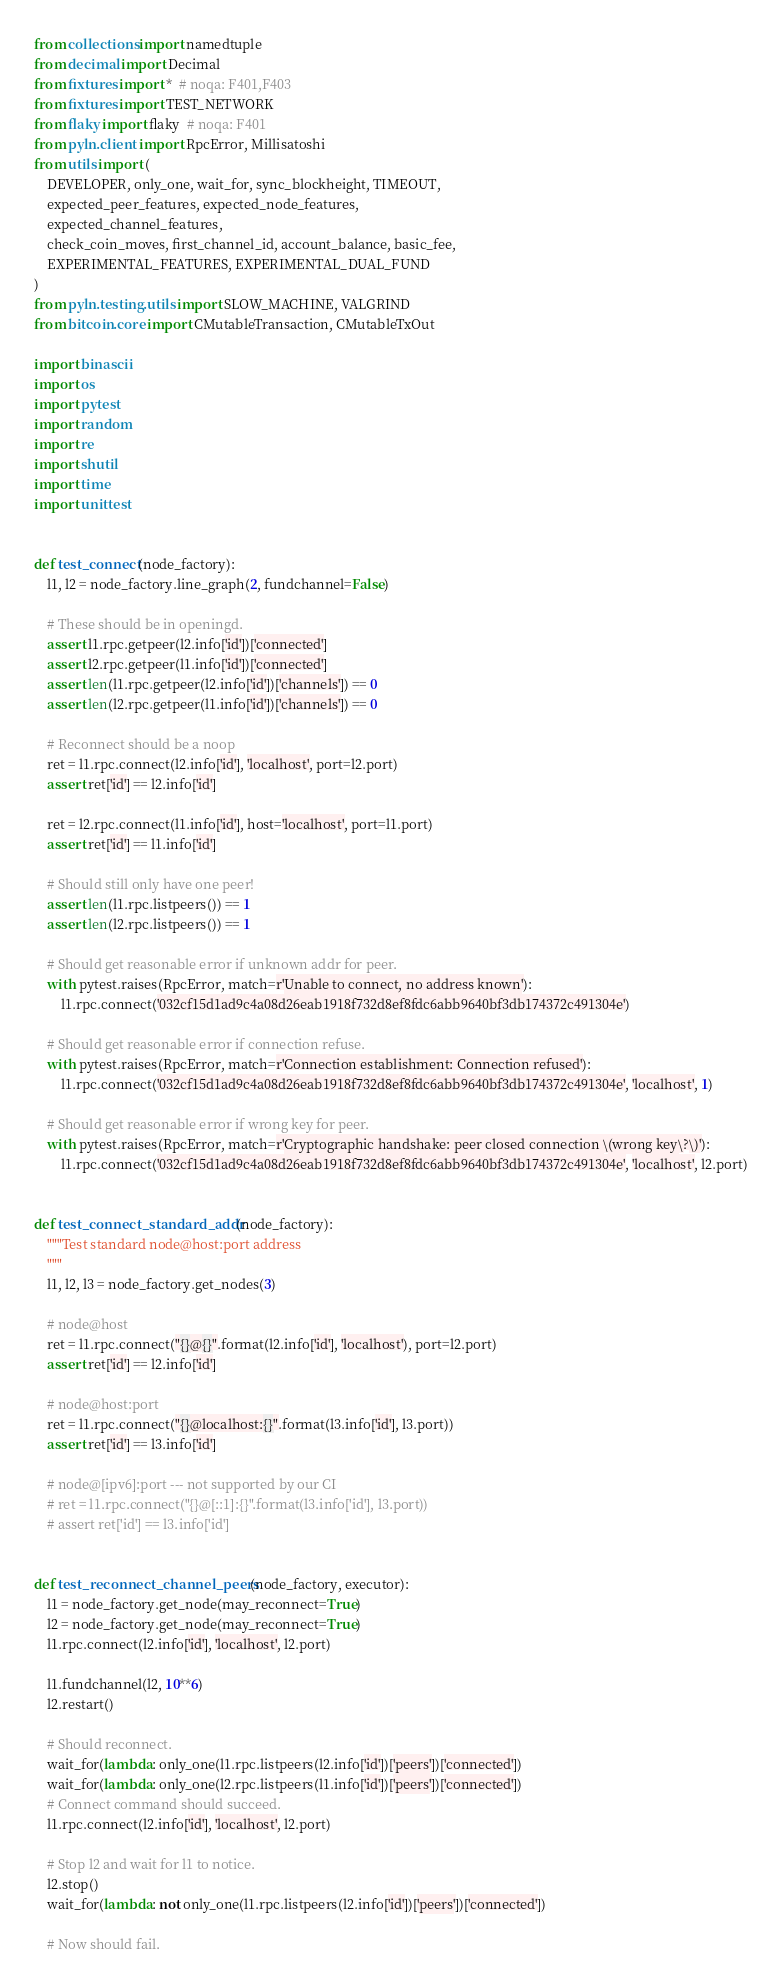Convert code to text. <code><loc_0><loc_0><loc_500><loc_500><_Python_>from collections import namedtuple
from decimal import Decimal
from fixtures import *  # noqa: F401,F403
from fixtures import TEST_NETWORK
from flaky import flaky  # noqa: F401
from pyln.client import RpcError, Millisatoshi
from utils import (
    DEVELOPER, only_one, wait_for, sync_blockheight, TIMEOUT,
    expected_peer_features, expected_node_features,
    expected_channel_features,
    check_coin_moves, first_channel_id, account_balance, basic_fee,
    EXPERIMENTAL_FEATURES, EXPERIMENTAL_DUAL_FUND
)
from pyln.testing.utils import SLOW_MACHINE, VALGRIND
from bitcoin.core import CMutableTransaction, CMutableTxOut

import binascii
import os
import pytest
import random
import re
import shutil
import time
import unittest


def test_connect(node_factory):
    l1, l2 = node_factory.line_graph(2, fundchannel=False)

    # These should be in openingd.
    assert l1.rpc.getpeer(l2.info['id'])['connected']
    assert l2.rpc.getpeer(l1.info['id'])['connected']
    assert len(l1.rpc.getpeer(l2.info['id'])['channels']) == 0
    assert len(l2.rpc.getpeer(l1.info['id'])['channels']) == 0

    # Reconnect should be a noop
    ret = l1.rpc.connect(l2.info['id'], 'localhost', port=l2.port)
    assert ret['id'] == l2.info['id']

    ret = l2.rpc.connect(l1.info['id'], host='localhost', port=l1.port)
    assert ret['id'] == l1.info['id']

    # Should still only have one peer!
    assert len(l1.rpc.listpeers()) == 1
    assert len(l2.rpc.listpeers()) == 1

    # Should get reasonable error if unknown addr for peer.
    with pytest.raises(RpcError, match=r'Unable to connect, no address known'):
        l1.rpc.connect('032cf15d1ad9c4a08d26eab1918f732d8ef8fdc6abb9640bf3db174372c491304e')

    # Should get reasonable error if connection refuse.
    with pytest.raises(RpcError, match=r'Connection establishment: Connection refused'):
        l1.rpc.connect('032cf15d1ad9c4a08d26eab1918f732d8ef8fdc6abb9640bf3db174372c491304e', 'localhost', 1)

    # Should get reasonable error if wrong key for peer.
    with pytest.raises(RpcError, match=r'Cryptographic handshake: peer closed connection \(wrong key\?\)'):
        l1.rpc.connect('032cf15d1ad9c4a08d26eab1918f732d8ef8fdc6abb9640bf3db174372c491304e', 'localhost', l2.port)


def test_connect_standard_addr(node_factory):
    """Test standard node@host:port address
    """
    l1, l2, l3 = node_factory.get_nodes(3)

    # node@host
    ret = l1.rpc.connect("{}@{}".format(l2.info['id'], 'localhost'), port=l2.port)
    assert ret['id'] == l2.info['id']

    # node@host:port
    ret = l1.rpc.connect("{}@localhost:{}".format(l3.info['id'], l3.port))
    assert ret['id'] == l3.info['id']

    # node@[ipv6]:port --- not supported by our CI
    # ret = l1.rpc.connect("{}@[::1]:{}".format(l3.info['id'], l3.port))
    # assert ret['id'] == l3.info['id']


def test_reconnect_channel_peers(node_factory, executor):
    l1 = node_factory.get_node(may_reconnect=True)
    l2 = node_factory.get_node(may_reconnect=True)
    l1.rpc.connect(l2.info['id'], 'localhost', l2.port)

    l1.fundchannel(l2, 10**6)
    l2.restart()

    # Should reconnect.
    wait_for(lambda: only_one(l1.rpc.listpeers(l2.info['id'])['peers'])['connected'])
    wait_for(lambda: only_one(l2.rpc.listpeers(l1.info['id'])['peers'])['connected'])
    # Connect command should succeed.
    l1.rpc.connect(l2.info['id'], 'localhost', l2.port)

    # Stop l2 and wait for l1 to notice.
    l2.stop()
    wait_for(lambda: not only_one(l1.rpc.listpeers(l2.info['id'])['peers'])['connected'])

    # Now should fail.</code> 